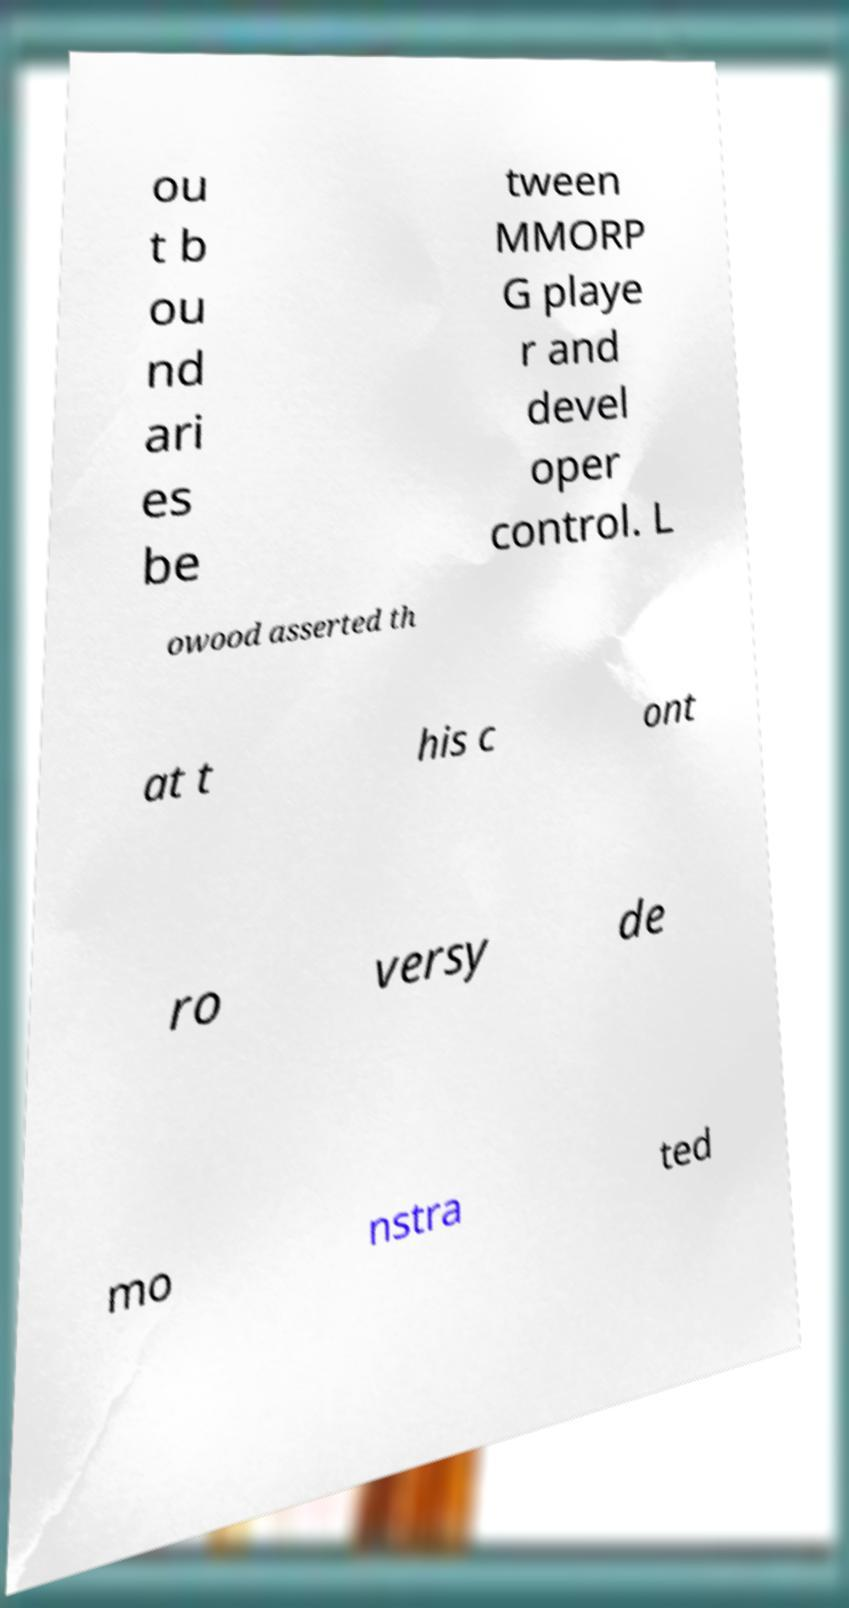Could you extract and type out the text from this image? ou t b ou nd ari es be tween MMORP G playe r and devel oper control. L owood asserted th at t his c ont ro versy de mo nstra ted 